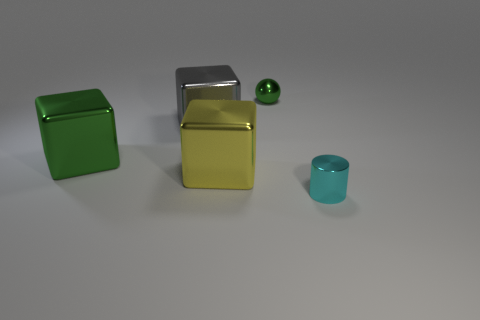There is a small thing that is on the left side of the small shiny thing that is in front of the tiny thing that is left of the cylinder; what is it made of?
Your response must be concise. Metal. Is the small cyan thing the same shape as the large green object?
Provide a succinct answer. No. What number of matte things are tiny green balls or green blocks?
Your answer should be very brief. 0. How many brown metallic spheres are there?
Provide a short and direct response. 0. There is a sphere that is the same size as the cyan thing; what is its color?
Your response must be concise. Green. Do the metal sphere and the metallic cylinder have the same size?
Offer a very short reply. Yes. The object that is the same color as the small ball is what shape?
Offer a terse response. Cube. Does the cyan metal object have the same size as the green shiny thing behind the large green shiny block?
Your answer should be compact. Yes. What is the color of the thing that is to the right of the yellow metal object and in front of the shiny sphere?
Your answer should be very brief. Cyan. Is the number of big shiny objects that are behind the shiny ball greater than the number of green cubes that are right of the gray shiny block?
Offer a very short reply. No. 